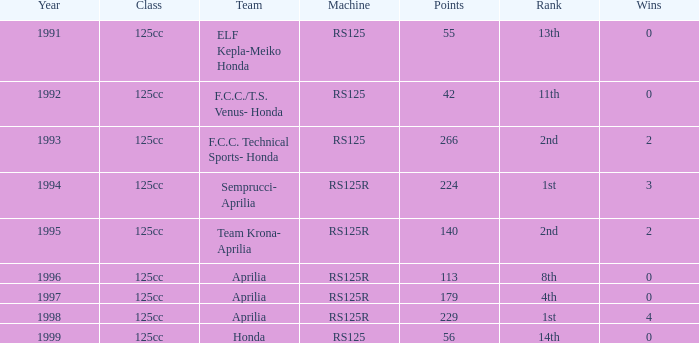When did a team from aprilia secure a 4th rank position? 1997.0. 